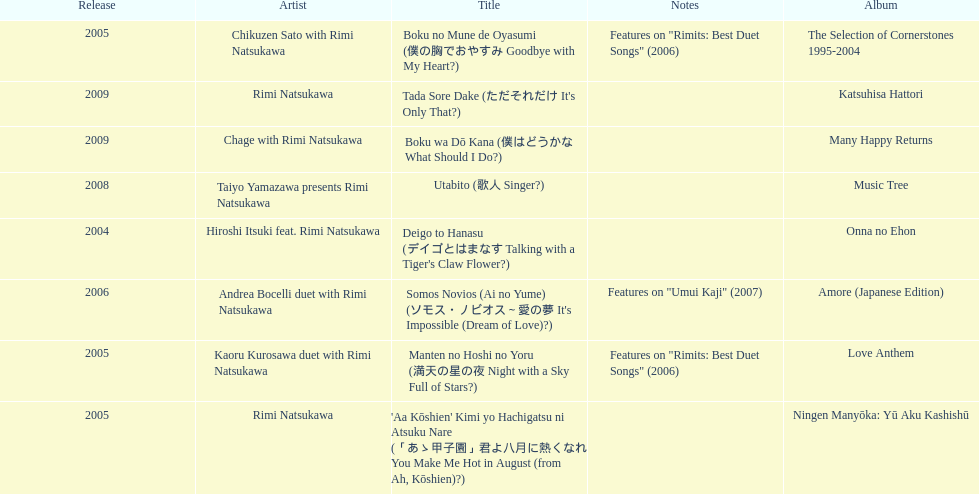What was the album released immediately before the one that had boku wa do kana on it? Music Tree. 